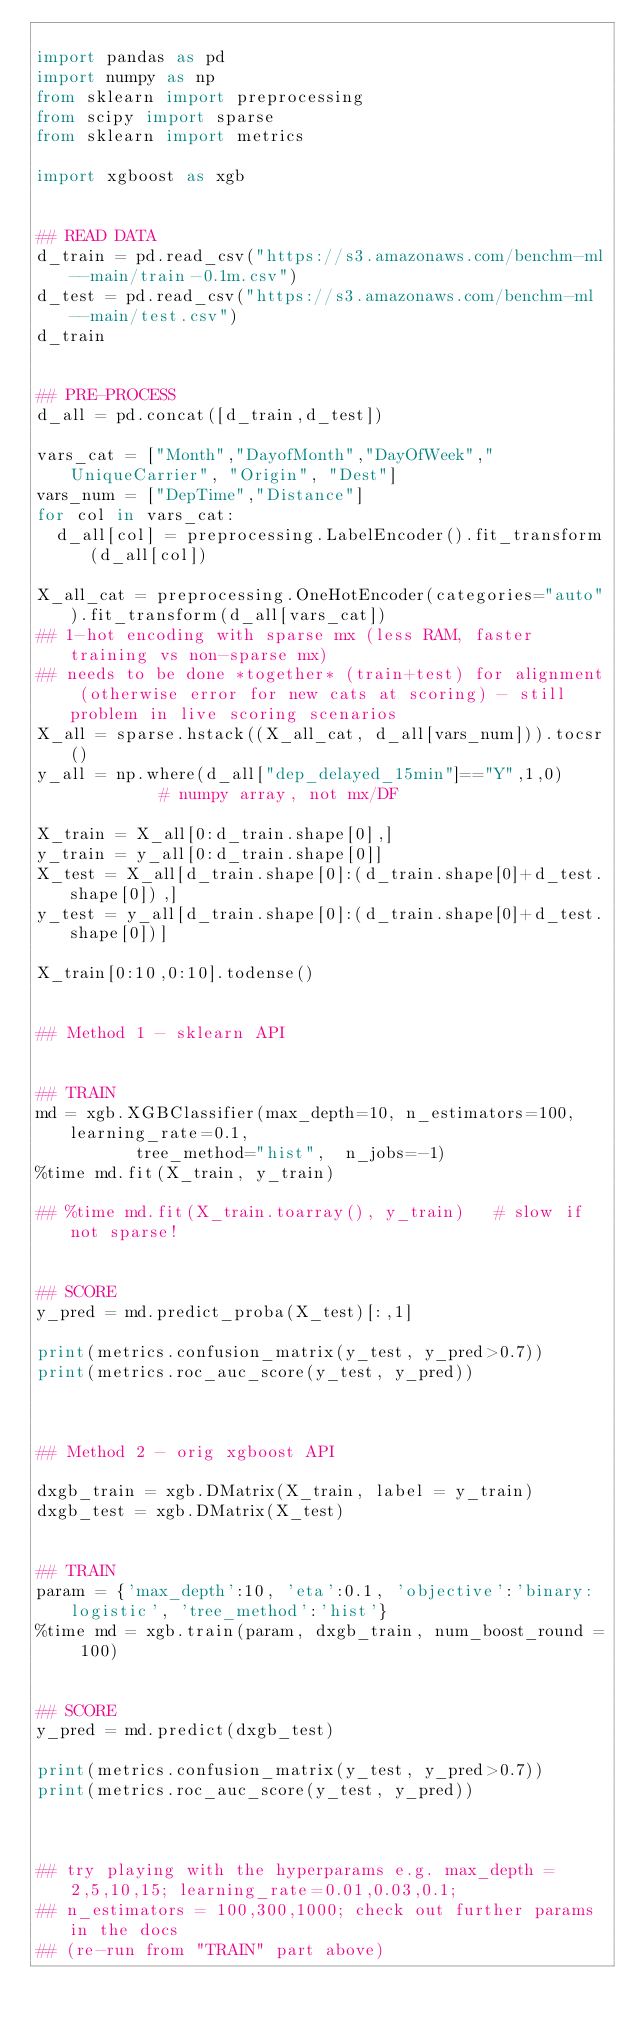<code> <loc_0><loc_0><loc_500><loc_500><_Python_>
import pandas as pd
import numpy as np
from sklearn import preprocessing 
from scipy import sparse
from sklearn import metrics

import xgboost as xgb


## READ DATA
d_train = pd.read_csv("https://s3.amazonaws.com/benchm-ml--main/train-0.1m.csv")
d_test = pd.read_csv("https://s3.amazonaws.com/benchm-ml--main/test.csv")
d_train


## PRE-PROCESS
d_all = pd.concat([d_train,d_test])

vars_cat = ["Month","DayofMonth","DayOfWeek","UniqueCarrier", "Origin", "Dest"]
vars_num = ["DepTime","Distance"]
for col in vars_cat:
  d_all[col] = preprocessing.LabelEncoder().fit_transform(d_all[col])
  
X_all_cat = preprocessing.OneHotEncoder(categories="auto").fit_transform(d_all[vars_cat])   
## 1-hot encoding with sparse mx (less RAM, faster training vs non-sparse mx) 
## needs to be done *together* (train+test) for alignment (otherwise error for new cats at scoring) - still problem in live scoring scenarios
X_all = sparse.hstack((X_all_cat, d_all[vars_num])).tocsr()                               
y_all = np.where(d_all["dep_delayed_15min"]=="Y",1,0)          # numpy array, not mx/DF

X_train = X_all[0:d_train.shape[0],]
y_train = y_all[0:d_train.shape[0]]
X_test = X_all[d_train.shape[0]:(d_train.shape[0]+d_test.shape[0]),]
y_test = y_all[d_train.shape[0]:(d_train.shape[0]+d_test.shape[0])]

X_train[0:10,0:10].todense()


## Method 1 - sklearn API


## TRAIN
md = xgb.XGBClassifier(max_depth=10, n_estimators=100, learning_rate=0.1, 
          tree_method="hist",  n_jobs=-1)
%time md.fit(X_train, y_train)

## %time md.fit(X_train.toarray(), y_train)   # slow if not sparse!


## SCORE
y_pred = md.predict_proba(X_test)[:,1]

print(metrics.confusion_matrix(y_test, y_pred>0.7))
print(metrics.roc_auc_score(y_test, y_pred))



## Method 2 - orig xgboost API

dxgb_train = xgb.DMatrix(X_train, label = y_train)
dxgb_test = xgb.DMatrix(X_test)


## TRAIN
param = {'max_depth':10, 'eta':0.1, 'objective':'binary:logistic', 'tree_method':'hist'}  
%time md = xgb.train(param, dxgb_train, num_boost_round = 100)


## SCORE
y_pred = md.predict(dxgb_test)   

print(metrics.confusion_matrix(y_test, y_pred>0.7))
print(metrics.roc_auc_score(y_test, y_pred))



## try playing with the hyperparams e.g. max_depth = 2,5,10,15; learning_rate=0.01,0.03,0.1;
## n_estimators = 100,300,1000; check out further params in the docs
## (re-run from "TRAIN" part above)


</code> 